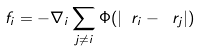Convert formula to latex. <formula><loc_0><loc_0><loc_500><loc_500>\ f _ { i } = - \nabla _ { i } \sum _ { j \neq i } \Phi ( | \ r _ { i } - \ r _ { j } | )</formula> 